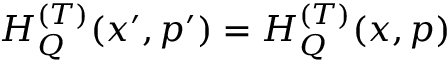Convert formula to latex. <formula><loc_0><loc_0><loc_500><loc_500>H _ { Q } ^ { ( T ) } ( x ^ { \prime } , p ^ { \prime } ) = H _ { Q } ^ { ( T ) } ( x , p )</formula> 